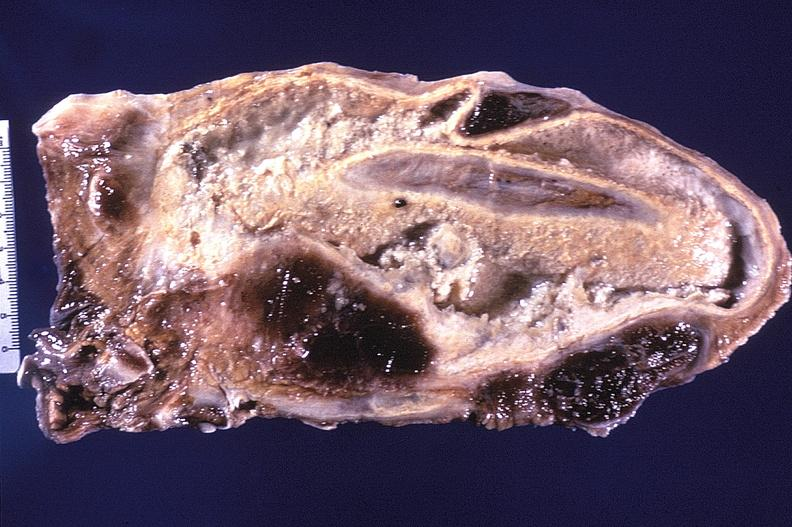s respiratory present?
Answer the question using a single word or phrase. Yes 